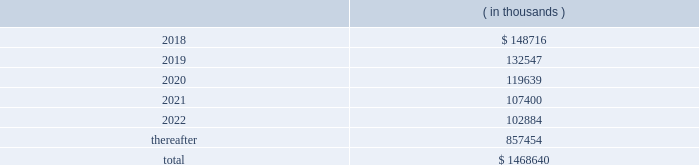Hollyfrontier corporation notes to consolidated financial statements continued .
Transportation and storage costs incurred under these agreements totaled $ 140.5 million , $ 135.1 million and $ 137.7 million for the years ended december 31 , 2017 , 2016 and 2015 , respectively .
These amounts do not include contractual commitments under our long-term transportation agreements with hep , as all transactions with hep are eliminated in these consolidated financial statements .
We have a crude oil supply contract that requires the supplier to deliver a specified volume of crude oil or pay a shortfall fee for the difference in the actual barrels delivered to us less the specified barrels per the supply contract .
For the contract year ended august 31 , 2017 , the actual number of barrels delivered to us was substantially less than the specified barrels , and we recorded a reduction to cost of goods sold and accumulated a shortfall fee receivable of $ 26.0 million during this period .
In september 2017 , the supplier notified us they are disputing the shortfall fee owed and in october 2017 notified us of their demand for arbitration .
We offset the receivable with payments of invoices for deliveries of crude oil received subsequent to august 31 , 2017 , which is permitted under the supply contract .
We believe the disputes and claims made by the supplier are without merit .
In march , 2006 , a subsidiary of ours sold the assets of montana refining company under an asset purchase agreement ( 201capa 201d ) .
Calumet montana refining llc , the current owner of the assets , has submitted requests for reimbursement of approximately $ 20.0 million pursuant to contractual indemnity provisions under the apa for various costs incurred , as well as additional claims related to environmental matters .
We have rejected most of the claims for payment , and this matter is scheduled for arbitration beginning in july 2018 .
We have accrued the costs we believe are owed pursuant to the apa , and we estimate that any reasonably possible losses beyond the amounts accrued are not material .
Note 20 : segment information effective fourth quarter of 2017 , we revised our reportable segments to align with certain changes in how our chief operating decision maker manages and allocates resources to our business .
Accordingly , our tulsa refineries 2019 lubricants operations , previously reported in the refining segment , are now combined with the operations of our petro-canada lubricants business ( acquired february 1 , 2017 ) and reported in the lubricants and specialty products segment .
Our prior period segment information has been retrospectively adjusted to reflect our current segment presentation .
Our operations are organized into three reportable segments , refining , lubricants and specialty products and hep .
Our operations that are not included in the refining , lubricants and specialty products and hep segments are included in corporate and other .
Intersegment transactions are eliminated in our consolidated financial statements and are included in eliminations .
Corporate and other and eliminations are aggregated and presented under corporate , other and eliminations column .
The refining segment represents the operations of the el dorado , tulsa , navajo , cheyenne and woods cross refineries and hfc asphalt ( aggregated as a reportable segment ) .
Refining activities involve the purchase and refining of crude oil and wholesale and branded marketing of refined products , such as gasoline , diesel fuel and jet fuel .
These petroleum products are primarily marketed in the mid-continent , southwest and rocky mountain regions of the united states .
Hfc asphalt operates various asphalt terminals in arizona , new mexico and oklahoma. .
What was the average storage costs from 2015 to 2017 in millions? 
Computations: ((137.7 + (140.5 + 135.1)) / 3)
Answer: 137.76667. 